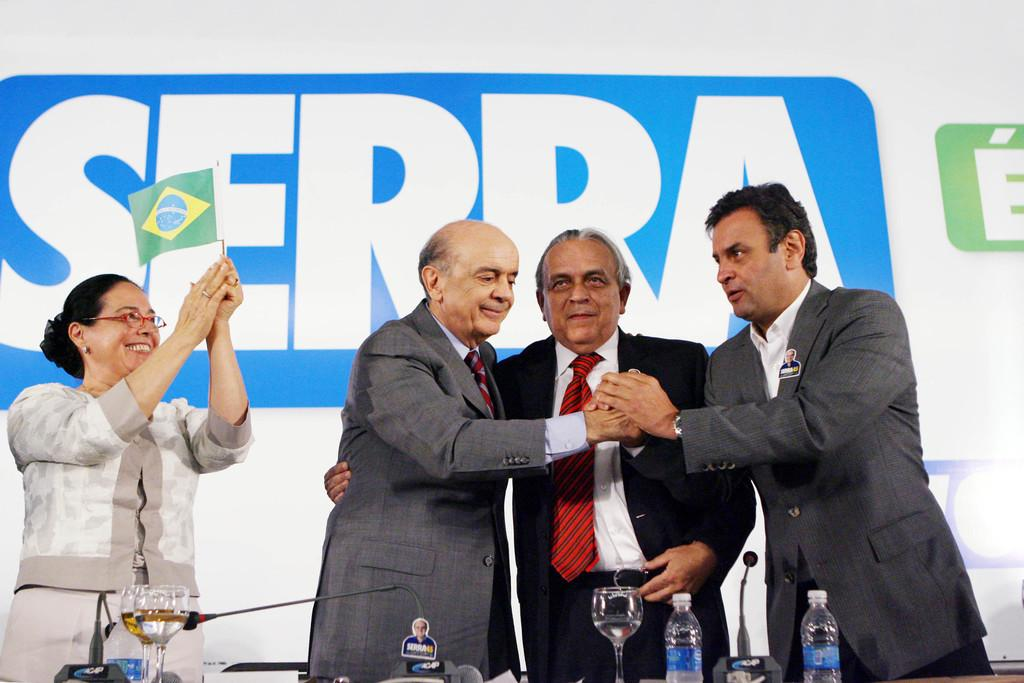How many people are in the image? There are three men and a woman in the image, making a total of four people. What are the people in the image doing? The people are standing and smiling in the image. What objects are in front of the people? There are bottles, glasses, and microphones in front of them. What can be seen in the background of the image? There is a banner in the background of the image. What scientific discovery was made by the woman in the image? There is no indication of a scientific discovery in the image; the woman is simply standing and smiling with the other people. Can you tell me how many sinks are visible in the image? There are no sinks present in the image. 